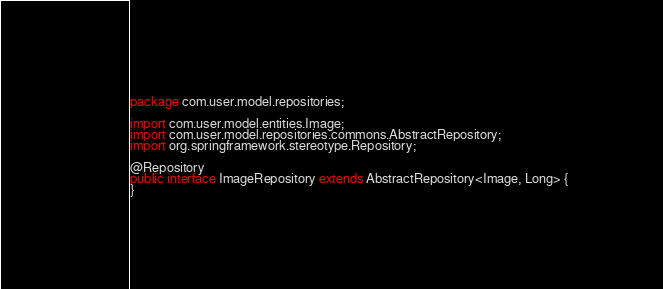<code> <loc_0><loc_0><loc_500><loc_500><_Java_>package com.user.model.repositories;

import com.user.model.entities.Image;
import com.user.model.repositories.commons.AbstractRepository;
import org.springframework.stereotype.Repository;

@Repository
public interface ImageRepository extends AbstractRepository<Image, Long> {
}
</code> 